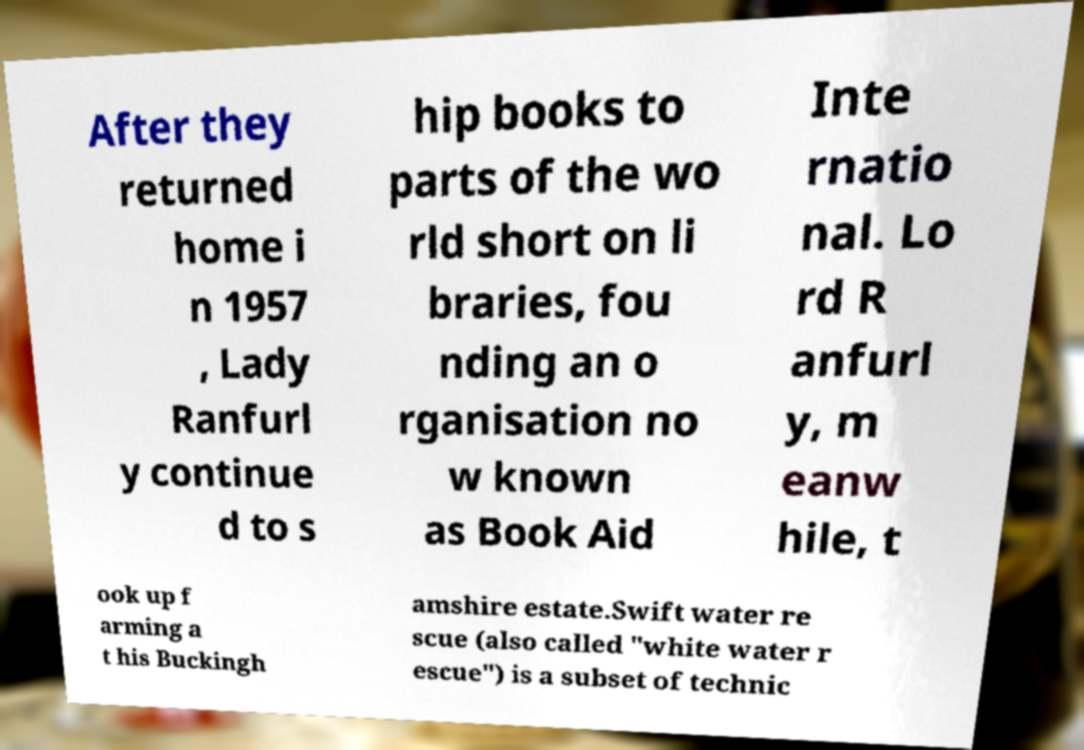For documentation purposes, I need the text within this image transcribed. Could you provide that? After they returned home i n 1957 , Lady Ranfurl y continue d to s hip books to parts of the wo rld short on li braries, fou nding an o rganisation no w known as Book Aid Inte rnatio nal. Lo rd R anfurl y, m eanw hile, t ook up f arming a t his Buckingh amshire estate.Swift water re scue (also called "white water r escue") is a subset of technic 